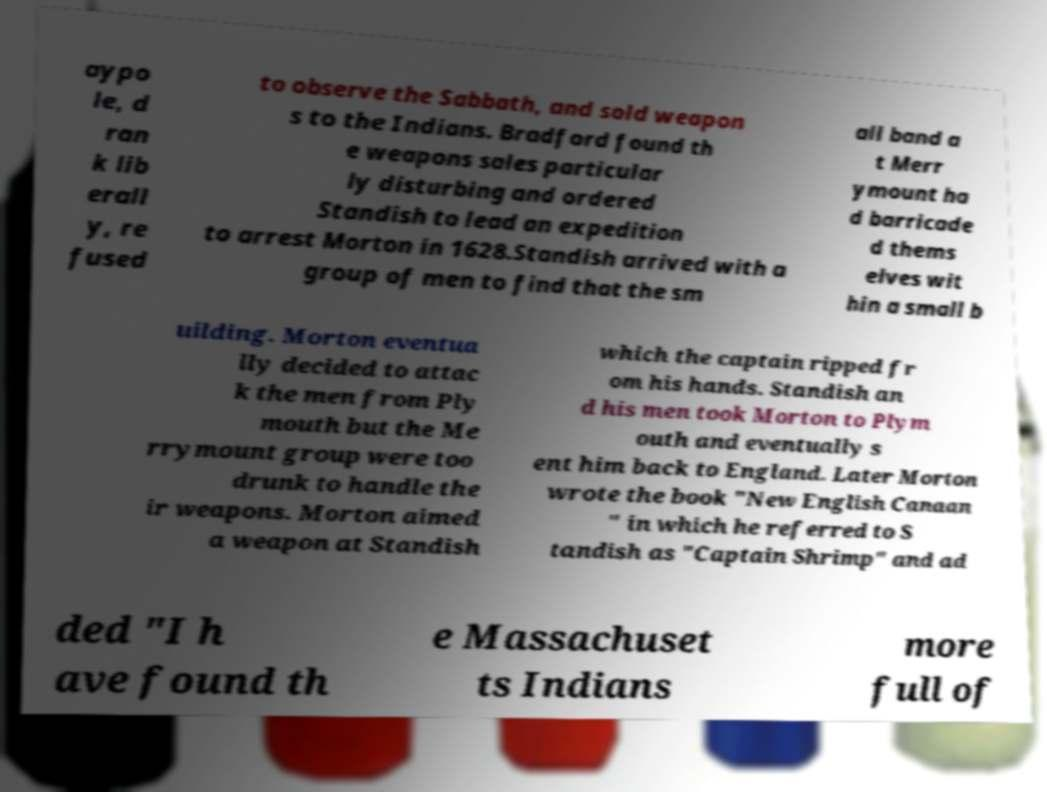Please identify and transcribe the text found in this image. aypo le, d ran k lib erall y, re fused to observe the Sabbath, and sold weapon s to the Indians. Bradford found th e weapons sales particular ly disturbing and ordered Standish to lead an expedition to arrest Morton in 1628.Standish arrived with a group of men to find that the sm all band a t Merr ymount ha d barricade d thems elves wit hin a small b uilding. Morton eventua lly decided to attac k the men from Ply mouth but the Me rrymount group were too drunk to handle the ir weapons. Morton aimed a weapon at Standish which the captain ripped fr om his hands. Standish an d his men took Morton to Plym outh and eventually s ent him back to England. Later Morton wrote the book "New English Canaan " in which he referred to S tandish as "Captain Shrimp" and ad ded "I h ave found th e Massachuset ts Indians more full of 